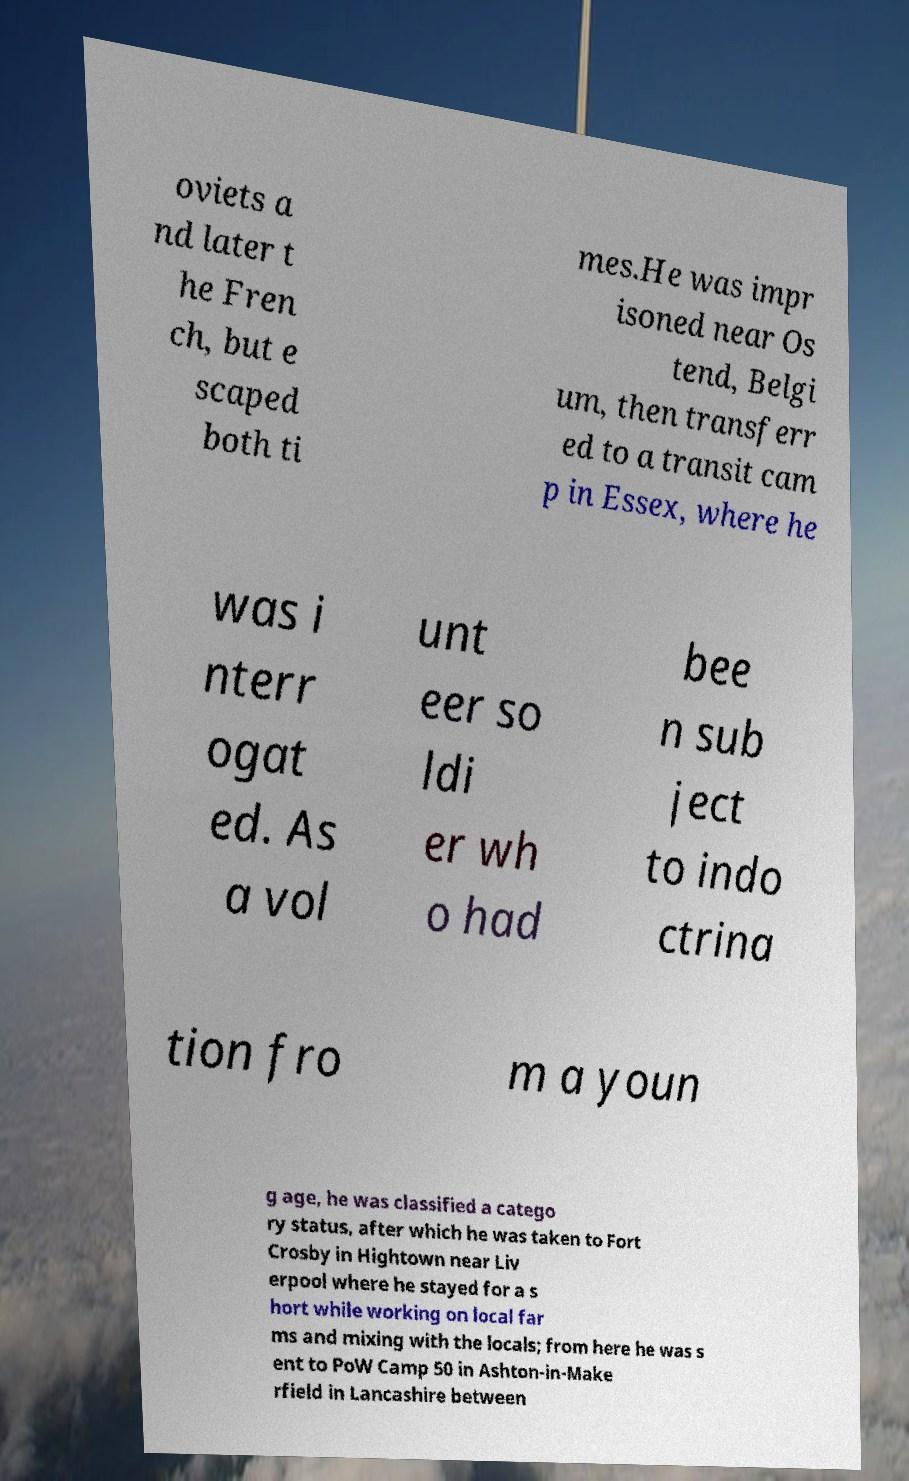Could you assist in decoding the text presented in this image and type it out clearly? oviets a nd later t he Fren ch, but e scaped both ti mes.He was impr isoned near Os tend, Belgi um, then transferr ed to a transit cam p in Essex, where he was i nterr ogat ed. As a vol unt eer so ldi er wh o had bee n sub ject to indo ctrina tion fro m a youn g age, he was classified a catego ry status, after which he was taken to Fort Crosby in Hightown near Liv erpool where he stayed for a s hort while working on local far ms and mixing with the locals; from here he was s ent to PoW Camp 50 in Ashton-in-Make rfield in Lancashire between 